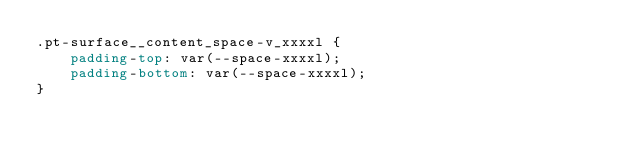Convert code to text. <code><loc_0><loc_0><loc_500><loc_500><_CSS_>.pt-surface__content_space-v_xxxxl {
	padding-top: var(--space-xxxxl);
	padding-bottom: var(--space-xxxxl);
}
</code> 